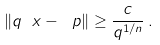Convert formula to latex. <formula><loc_0><loc_0><loc_500><loc_500>\| q \ x - \ p \| \geq \frac { c } { q ^ { 1 / n } } \, .</formula> 